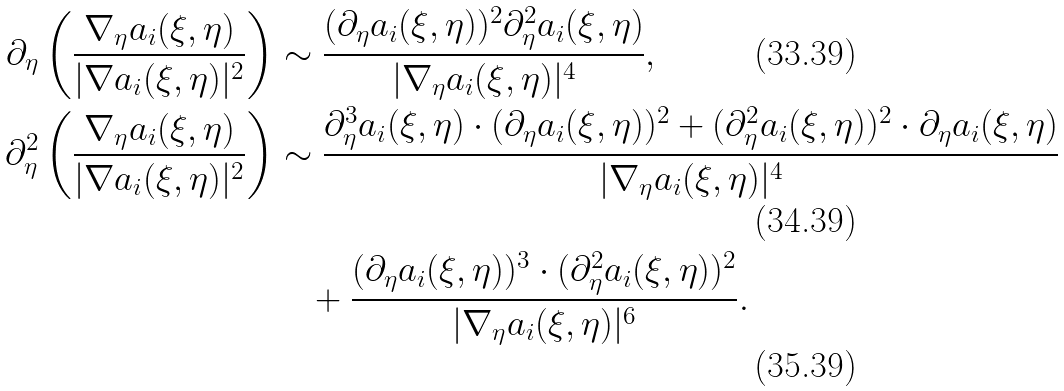<formula> <loc_0><loc_0><loc_500><loc_500>\partial _ { \eta } \left ( \frac { \nabla _ { \eta } a _ { i } ( \xi , \eta ) } { | \nabla a _ { i } ( \xi , \eta ) | ^ { 2 } } \right ) & \sim \frac { ( \partial _ { \eta } a _ { i } ( \xi , \eta ) ) ^ { 2 } \partial _ { \eta } ^ { 2 } a _ { i } ( \xi , \eta ) } { | \nabla _ { \eta } a _ { i } ( \xi , \eta ) | ^ { 4 } } , \\ \partial _ { \eta } ^ { 2 } \left ( \frac { \nabla _ { \eta } a _ { i } ( \xi , \eta ) } { | \nabla a _ { i } ( \xi , \eta ) | ^ { 2 } } \right ) & \sim \frac { \partial _ { \eta } ^ { 3 } a _ { i } ( \xi , \eta ) \cdot ( \partial _ { \eta } a _ { i } ( \xi , \eta ) ) ^ { 2 } + ( \partial _ { \eta } ^ { 2 } a _ { i } ( \xi , \eta ) ) ^ { 2 } \cdot \partial _ { \eta } a _ { i } ( \xi , \eta ) } { | \nabla _ { \eta } a _ { i } ( \xi , \eta ) | ^ { 4 } } \\ & \quad + \frac { ( \partial _ { \eta } a _ { i } ( \xi , \eta ) ) ^ { 3 } \cdot ( \partial _ { \eta } ^ { 2 } a _ { i } ( \xi , \eta ) ) ^ { 2 } } { | \nabla _ { \eta } a _ { i } ( \xi , \eta ) | ^ { 6 } } .</formula> 